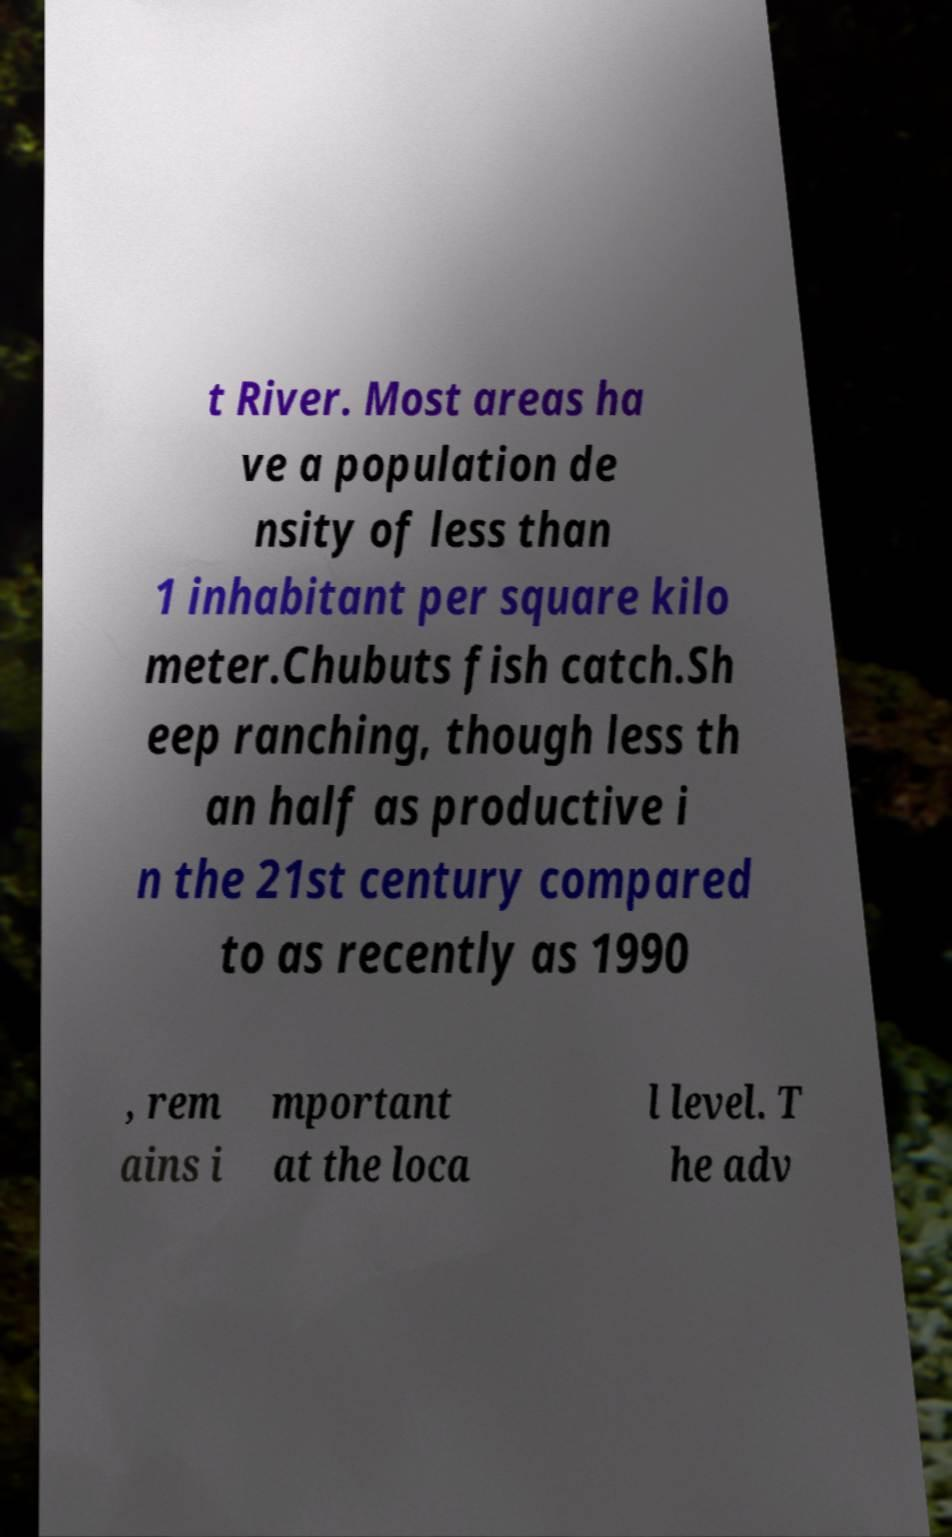There's text embedded in this image that I need extracted. Can you transcribe it verbatim? t River. Most areas ha ve a population de nsity of less than 1 inhabitant per square kilo meter.Chubuts fish catch.Sh eep ranching, though less th an half as productive i n the 21st century compared to as recently as 1990 , rem ains i mportant at the loca l level. T he adv 